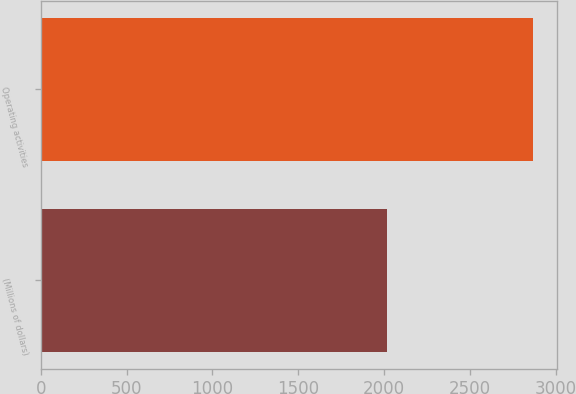Convert chart to OTSL. <chart><loc_0><loc_0><loc_500><loc_500><bar_chart><fcel>(Millions of dollars)<fcel>Operating activities<nl><fcel>2018<fcel>2865<nl></chart> 